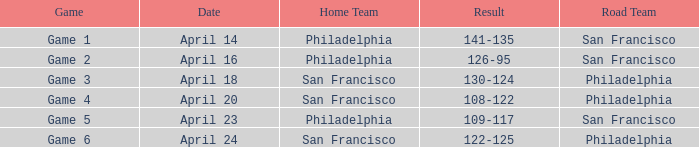On what date was game 2 played? April 16. 